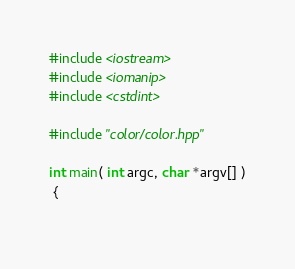<code> <loc_0><loc_0><loc_500><loc_500><_C++_>#include <iostream>
#include <iomanip>
#include <cstdint>

#include "color/color.hpp"

int main( int argc, char *argv[] )
 {
  </code> 